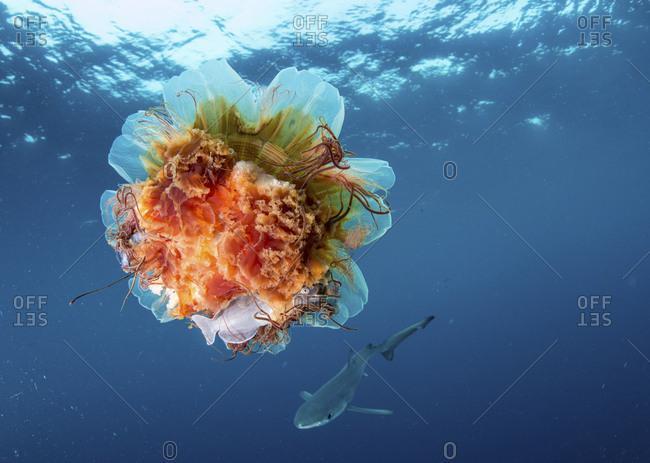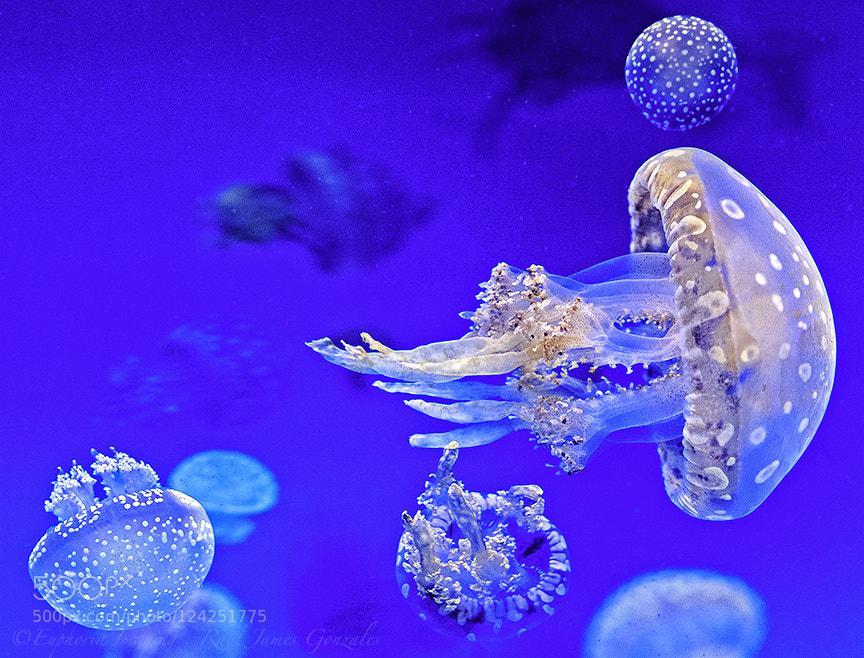The first image is the image on the left, the second image is the image on the right. Considering the images on both sides, is "The left image features one orange-capped jellyfish moving horizontally with threadlike and ruffled-look tentacles trailing behind it." valid? Answer yes or no. No. The first image is the image on the left, the second image is the image on the right. Given the left and right images, does the statement "At least one jellyfish has a polka dot body." hold true? Answer yes or no. Yes. 